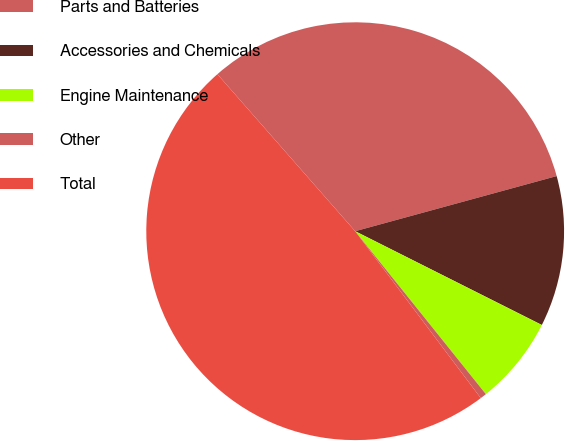Convert chart to OTSL. <chart><loc_0><loc_0><loc_500><loc_500><pie_chart><fcel>Parts and Batteries<fcel>Accessories and Chemicals<fcel>Engine Maintenance<fcel>Other<fcel>Total<nl><fcel>32.21%<fcel>11.66%<fcel>6.83%<fcel>0.49%<fcel>48.8%<nl></chart> 